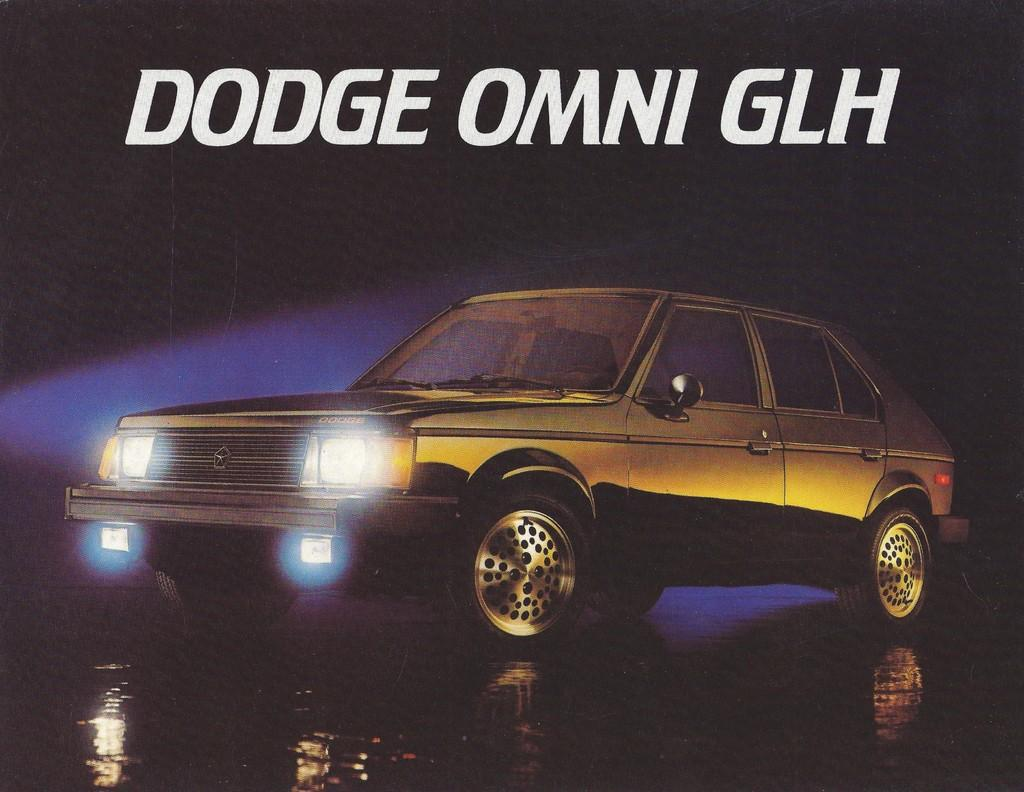What is the main subject of the image? The main subject of the image is a car. Where is the car located in the image? The car is on land in the image. What else can be seen in the image besides the car? There is some water visible in the image. What is present at the top of the image? There is text at the top of the image. What type of event is taking place in the image involving bikes and dolls? There is no event involving bikes and dolls present in the image; it features a car on land with some water visible and text at the top. 